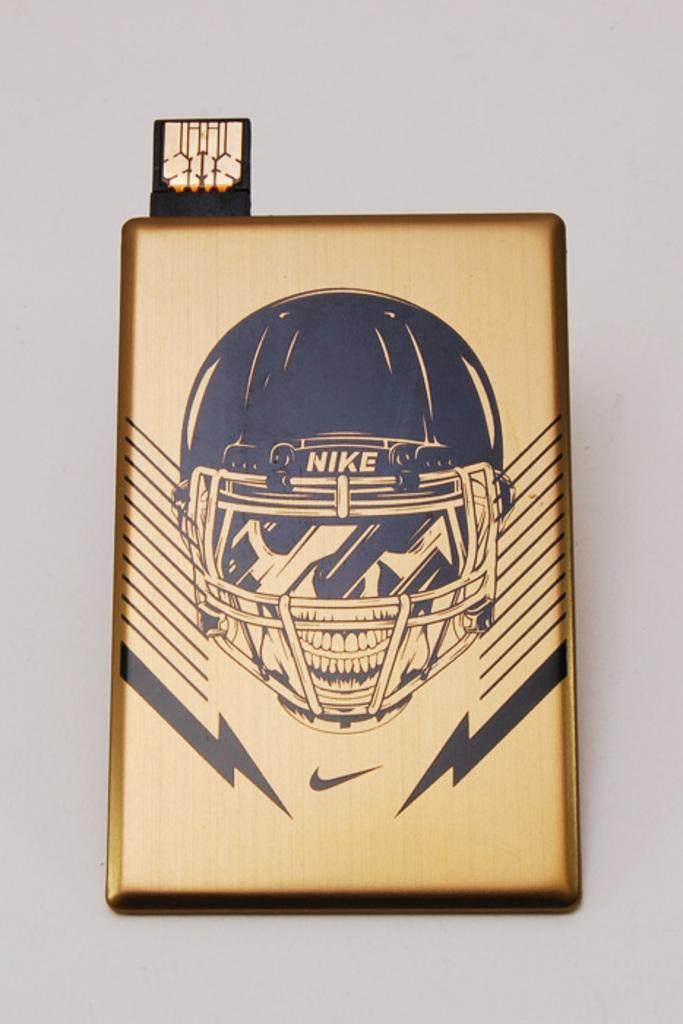In one or two sentences, can you explain what this image depicts? In this image we can see the art of a person wearing the helmet on the brass sheet block and it is on the wall 